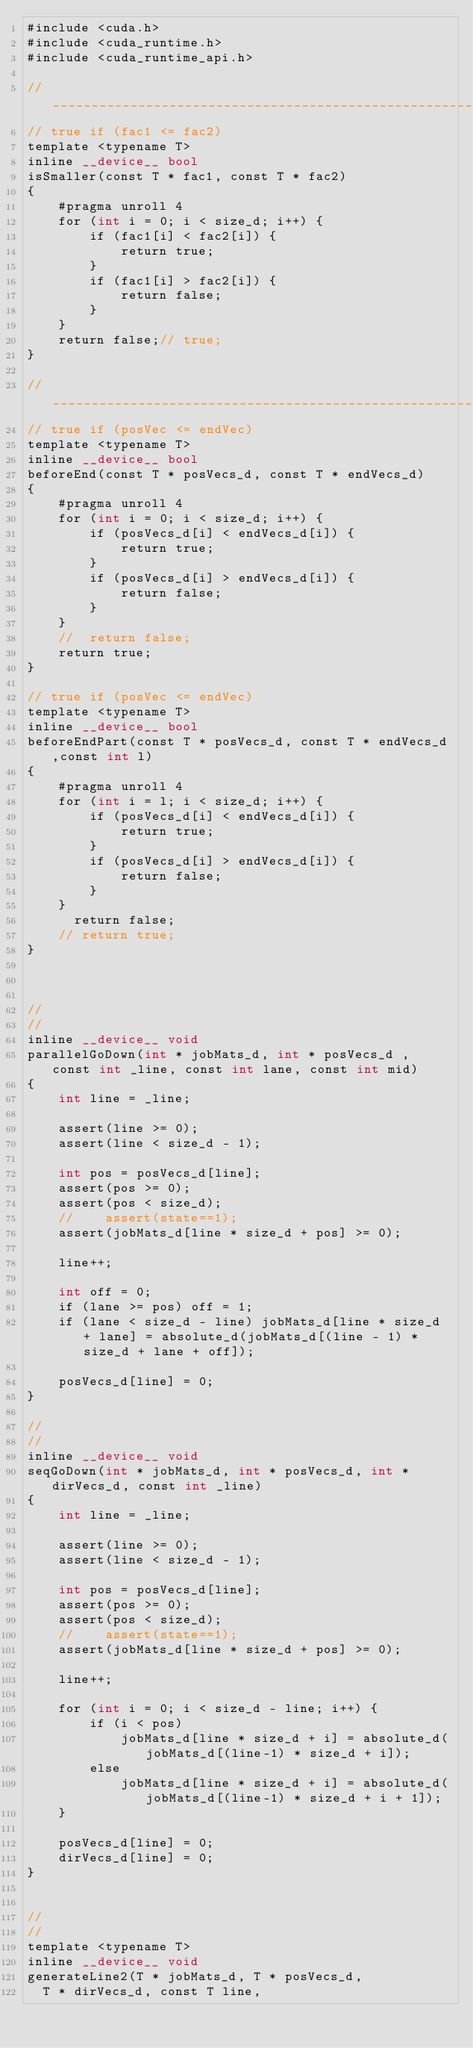<code> <loc_0><loc_0><loc_500><loc_500><_Cuda_>#include <cuda.h>
#include <cuda_runtime.h>
#include <cuda_runtime_api.h>

// __________________________________________________________
// true if (fac1 <= fac2)
template <typename T>
inline __device__ bool
isSmaller(const T * fac1, const T * fac2)
{
    #pragma unroll 4
    for (int i = 0; i < size_d; i++) {
        if (fac1[i] < fac2[i]) {
            return true;
        }
        if (fac1[i] > fac2[i]) {
            return false;
        }
    }
    return false;// true;
}

// __________________________________________________________
// true if (posVec <= endVec)
template <typename T>
inline __device__ bool
beforeEnd(const T * posVecs_d, const T * endVecs_d)
{
    #pragma unroll 4
    for (int i = 0; i < size_d; i++) {
        if (posVecs_d[i] < endVecs_d[i]) {
            return true;
        }
        if (posVecs_d[i] > endVecs_d[i]) {
            return false;
        }
    }
    //	return false;
    return true;
}

// true if (posVec <= endVec)
template <typename T>
inline __device__ bool
beforeEndPart(const T * posVecs_d, const T * endVecs_d,const int l)
{
    #pragma unroll 4
    for (int i = l; i < size_d; i++) {
        if (posVecs_d[i] < endVecs_d[i]) {
            return true;
        }
        if (posVecs_d[i] > endVecs_d[i]) {
            return false;
        }
    }
    	return false;
    // return true;
}



//
//
inline __device__ void
parallelGoDown(int * jobMats_d, int * posVecs_d , const int _line, const int lane, const int mid)
{
    int line = _line;

    assert(line >= 0);
    assert(line < size_d - 1);

    int pos = posVecs_d[line];
    assert(pos >= 0);
    assert(pos < size_d);
    //    assert(state==1);
    assert(jobMats_d[line * size_d + pos] >= 0);

    line++;

    int off = 0;
    if (lane >= pos) off = 1;
    if (lane < size_d - line) jobMats_d[line * size_d + lane] = absolute_d(jobMats_d[(line - 1) * size_d + lane + off]);

    posVecs_d[line] = 0;
}

//
//
inline __device__ void
seqGoDown(int * jobMats_d, int * posVecs_d, int * dirVecs_d, const int _line)
{
    int line = _line;

    assert(line >= 0);
    assert(line < size_d - 1);

    int pos = posVecs_d[line];
    assert(pos >= 0);
    assert(pos < size_d);
    //    assert(state==1);
    assert(jobMats_d[line * size_d + pos] >= 0);

    line++;

    for (int i = 0; i < size_d - line; i++) {
        if (i < pos)
            jobMats_d[line * size_d + i] = absolute_d(jobMats_d[(line-1) * size_d + i]);
        else
            jobMats_d[line * size_d + i] = absolute_d(jobMats_d[(line-1) * size_d + i + 1]);
    }

    posVecs_d[line] = 0;
    dirVecs_d[line] = 0;
}


//
//
template <typename T>
inline __device__ void
generateLine2(T * jobMats_d, T * posVecs_d,
  T * dirVecs_d, const T line,</code> 